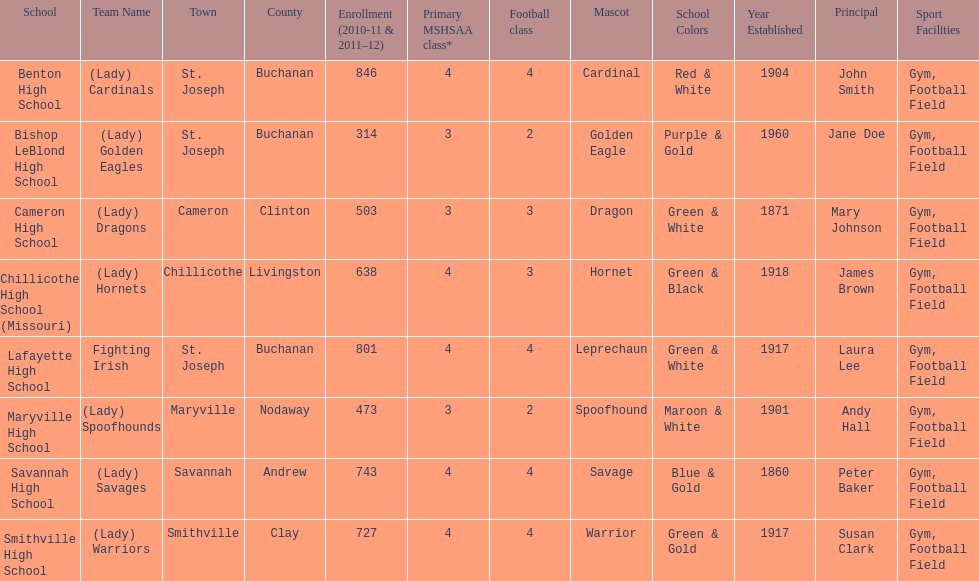What is the number of football classes lafayette high school has? 4. 